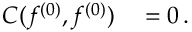Convert formula to latex. <formula><loc_0><loc_0><loc_500><loc_500>\begin{array} { r l } { C ( f ^ { ( 0 ) } , f ^ { ( 0 ) } ) } & = 0 \, . } \end{array}</formula> 